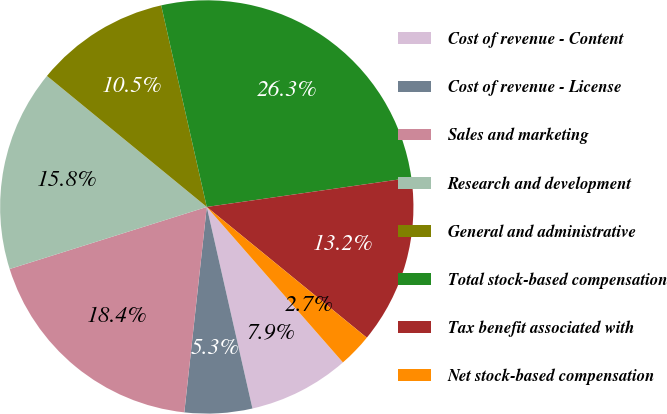Convert chart to OTSL. <chart><loc_0><loc_0><loc_500><loc_500><pie_chart><fcel>Cost of revenue - Content<fcel>Cost of revenue - License<fcel>Sales and marketing<fcel>Research and development<fcel>General and administrative<fcel>Total stock-based compensation<fcel>Tax benefit associated with<fcel>Net stock-based compensation<nl><fcel>7.9%<fcel>5.28%<fcel>18.41%<fcel>15.78%<fcel>10.53%<fcel>26.28%<fcel>13.16%<fcel>2.65%<nl></chart> 